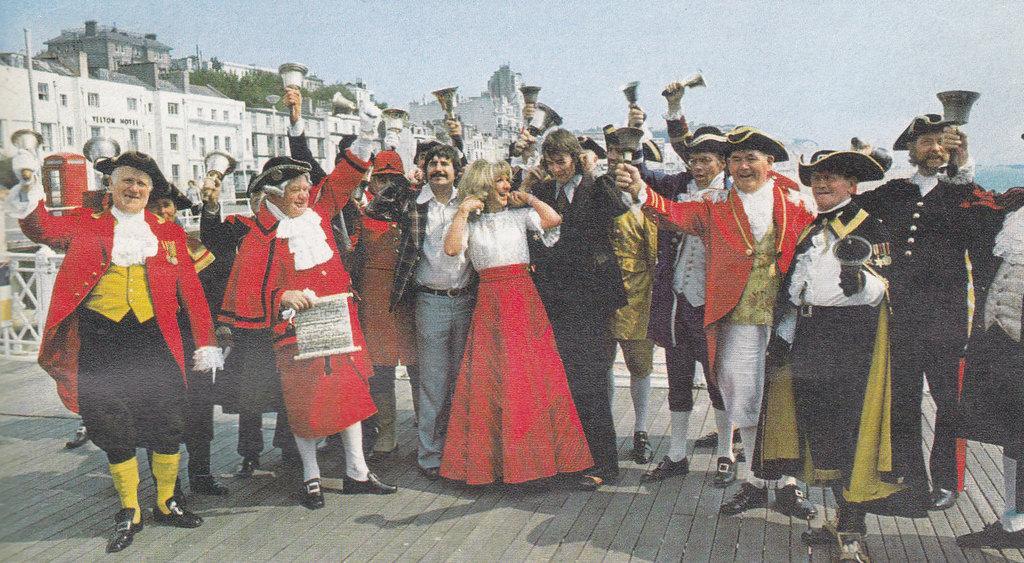In one or two sentences, can you explain what this image depicts? We see a group of people in front of us and we see that they are very happy and few of them are holding bells in their hands. We see a few buildings in the background, which are painted with white color and the sky is pretty clear. 